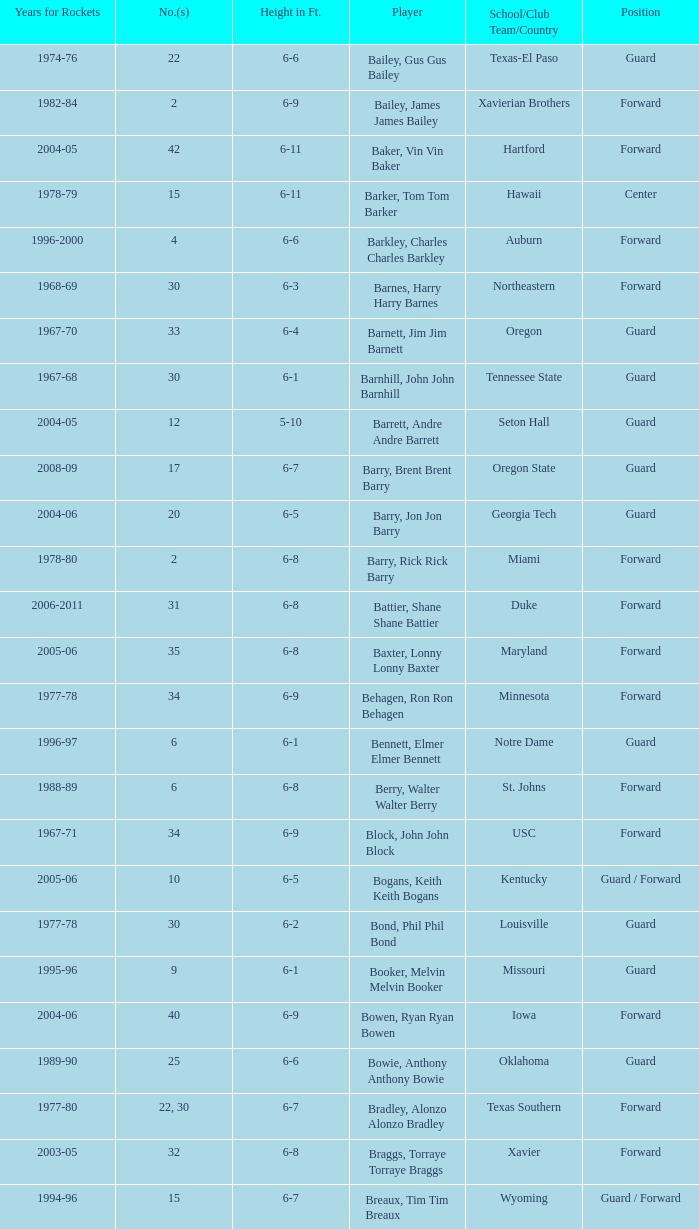What position is number 35 whose height is 6-6? Forward. Can you parse all the data within this table? {'header': ['Years for Rockets', 'No.(s)', 'Height in Ft.', 'Player', 'School/Club Team/Country', 'Position'], 'rows': [['1974-76', '22', '6-6', 'Bailey, Gus Gus Bailey', 'Texas-El Paso', 'Guard'], ['1982-84', '2', '6-9', 'Bailey, James James Bailey', 'Xavierian Brothers', 'Forward'], ['2004-05', '42', '6-11', 'Baker, Vin Vin Baker', 'Hartford', 'Forward'], ['1978-79', '15', '6-11', 'Barker, Tom Tom Barker', 'Hawaii', 'Center'], ['1996-2000', '4', '6-6', 'Barkley, Charles Charles Barkley', 'Auburn', 'Forward'], ['1968-69', '30', '6-3', 'Barnes, Harry Harry Barnes', 'Northeastern', 'Forward'], ['1967-70', '33', '6-4', 'Barnett, Jim Jim Barnett', 'Oregon', 'Guard'], ['1967-68', '30', '6-1', 'Barnhill, John John Barnhill', 'Tennessee State', 'Guard'], ['2004-05', '12', '5-10', 'Barrett, Andre Andre Barrett', 'Seton Hall', 'Guard'], ['2008-09', '17', '6-7', 'Barry, Brent Brent Barry', 'Oregon State', 'Guard'], ['2004-06', '20', '6-5', 'Barry, Jon Jon Barry', 'Georgia Tech', 'Guard'], ['1978-80', '2', '6-8', 'Barry, Rick Rick Barry', 'Miami', 'Forward'], ['2006-2011', '31', '6-8', 'Battier, Shane Shane Battier', 'Duke', 'Forward'], ['2005-06', '35', '6-8', 'Baxter, Lonny Lonny Baxter', 'Maryland', 'Forward'], ['1977-78', '34', '6-9', 'Behagen, Ron Ron Behagen', 'Minnesota', 'Forward'], ['1996-97', '6', '6-1', 'Bennett, Elmer Elmer Bennett', 'Notre Dame', 'Guard'], ['1988-89', '6', '6-8', 'Berry, Walter Walter Berry', 'St. Johns', 'Forward'], ['1967-71', '34', '6-9', 'Block, John John Block', 'USC', 'Forward'], ['2005-06', '10', '6-5', 'Bogans, Keith Keith Bogans', 'Kentucky', 'Guard / Forward'], ['1977-78', '30', '6-2', 'Bond, Phil Phil Bond', 'Louisville', 'Guard'], ['1995-96', '9', '6-1', 'Booker, Melvin Melvin Booker', 'Missouri', 'Guard'], ['2004-06', '40', '6-9', 'Bowen, Ryan Ryan Bowen', 'Iowa', 'Forward'], ['1989-90', '25', '6-6', 'Bowie, Anthony Anthony Bowie', 'Oklahoma', 'Guard'], ['1977-80', '22, 30', '6-7', 'Bradley, Alonzo Alonzo Bradley', 'Texas Southern', 'Forward'], ['2003-05', '32', '6-8', 'Braggs, Torraye Torraye Braggs', 'Xavier', 'Forward'], ['1994-96', '15', '6-7', 'Breaux, Tim Tim Breaux', 'Wyoming', 'Guard / Forward'], ['1967-68', '31', '6-4', 'Britt, Tyrone Tyrone Britt', 'Johnson C. Smith', 'Guard'], ['2007-2011, 2013', '0', '6-0', 'Brooks, Aaron Aaron Brooks', 'Oregon', 'Guard'], ['1992-95', '1', '5-11', 'Brooks, Scott Scott Brooks', 'UC-Irvine', 'Guard'], ['1994-96', '52', '6-8', 'Brown, Chucky Chucky Brown', 'North Carolina', 'Forward'], ['1988-89', '35', '6-6', 'Brown, Tony Tony Brown', 'Arkansas', 'Forward'], ['2001-02', '10', '6-2', 'Brown, Tierre Tierre Brown', 'McNesse State', 'Guard'], ['2005-06', '9', '6-4', 'Brunson, Rick Rick Brunson', 'Temple', 'Guard'], ['1982-83', '22', '6-9', 'Bryant, Joe Joe Bryant', 'LaSalle', 'Forward / Guard'], ['1995-96', '2', '6-9', 'Bryant, Mark Mark Bryant', 'Seton Hall', 'Forward'], ['2009-2012', '10', '6-7', 'Budinger, Chase Chase Budinger', 'Arizona', 'Forward'], ['1990-94, 1996-2001', '50', '6-10', 'Bullard, Matt Matt Bullard', 'Iowa', 'Forward']]} 